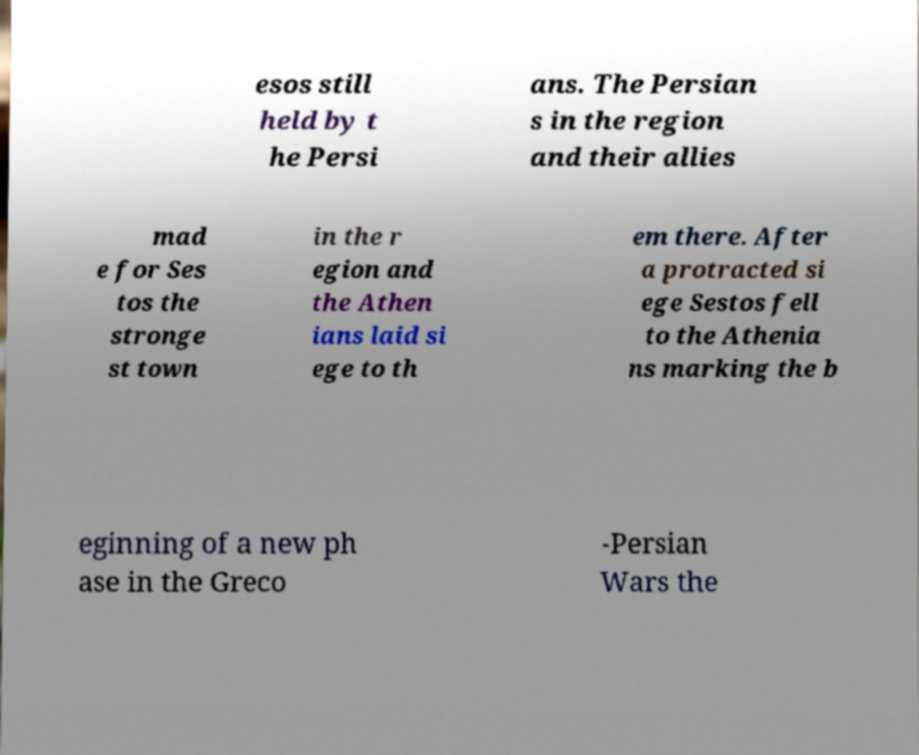Please read and relay the text visible in this image. What does it say? esos still held by t he Persi ans. The Persian s in the region and their allies mad e for Ses tos the stronge st town in the r egion and the Athen ians laid si ege to th em there. After a protracted si ege Sestos fell to the Athenia ns marking the b eginning of a new ph ase in the Greco -Persian Wars the 